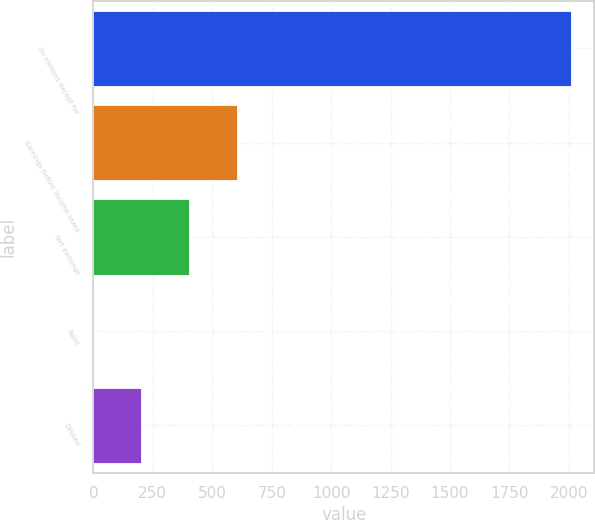<chart> <loc_0><loc_0><loc_500><loc_500><bar_chart><fcel>(In millions except for<fcel>Earnings before income taxes<fcel>Net earnings<fcel>Basic<fcel>Diluted<nl><fcel>2007<fcel>602.13<fcel>401.44<fcel>0.06<fcel>200.75<nl></chart> 